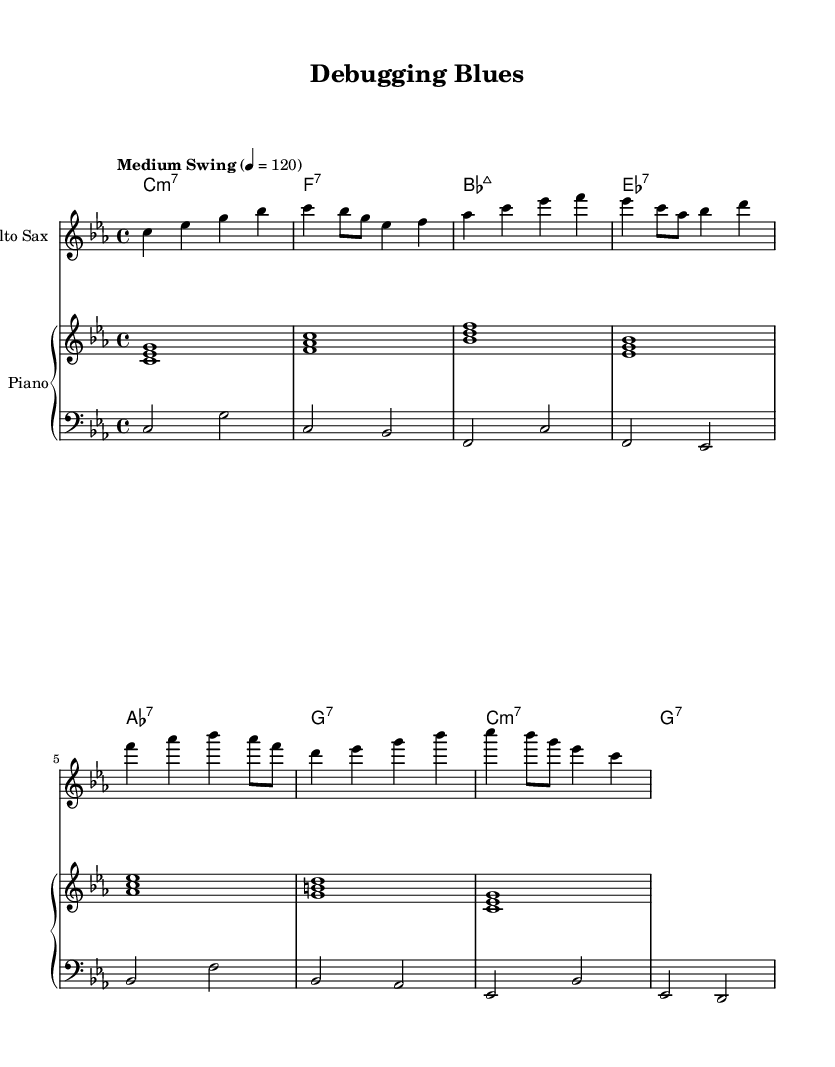What is the key signature of this music? The key signature is C minor, which has three flats (B-flat, E-flat, and A-flat). This is determined by the global section where the key is declared.
Answer: C minor What is the time signature of this music? The time signature is found in the global section as well, and it is indicated as 4/4, meaning there are four beats in each measure.
Answer: 4/4 What is the tempo marking used in this piece? The tempo marking is indicated as "Medium Swing" with a speed of 4 = 120, which suggests a moderate swing feel at a tempo of 120 beats per minute.
Answer: Medium Swing How many measures does the saxophone part consist of? By visually counting the measures in the saxophone staff from beginning to end, it confirms 8 distinct measures of music.
Answer: 8 What type of chords are primarily used in the piece? The chord names reveal that the piece uses minor and seventh chords, including C minor 7, F7, B-flat major 7, E-flat 7, A-flat 7, G7, and repeats with C minor 7 and G7.
Answer: Minor and seventh chords What swing feel is implied in this composition? The term "Medium Swing" in the tempo marking indicates that the piece should be played with a light, swinging rhythm typical in jazz. This informs the musician to interpret the eighth notes with a triplet feel.
Answer: Swing What instrument has the melody in this piece? The alto saxophone part is the highest staff in the score, which indicates that it carries the melody. This can be inferred by its placement and the absence of similar melodic lines in the piano and bass parts.
Answer: Alto Sax 